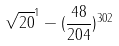<formula> <loc_0><loc_0><loc_500><loc_500>\sqrt { 2 0 } ^ { 1 } - ( \frac { 4 8 } { 2 0 4 } ) ^ { 3 0 2 }</formula> 